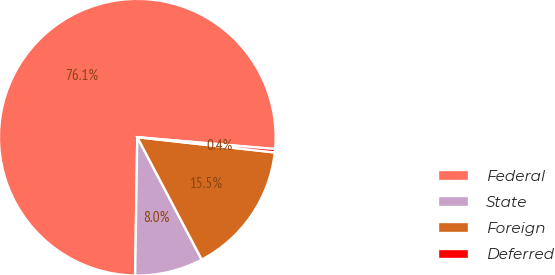Convert chart to OTSL. <chart><loc_0><loc_0><loc_500><loc_500><pie_chart><fcel>Federal<fcel>State<fcel>Foreign<fcel>Deferred<nl><fcel>76.12%<fcel>7.96%<fcel>15.53%<fcel>0.39%<nl></chart> 